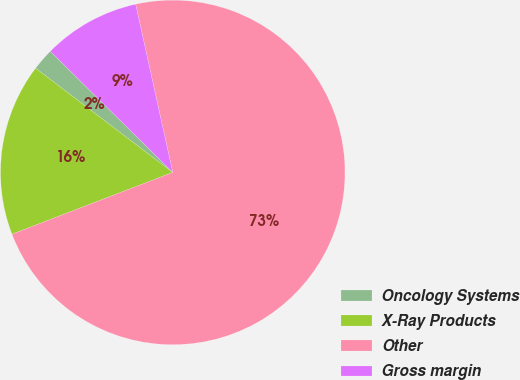<chart> <loc_0><loc_0><loc_500><loc_500><pie_chart><fcel>Oncology Systems<fcel>X-Ray Products<fcel>Other<fcel>Gross margin<nl><fcel>2.07%<fcel>16.18%<fcel>72.61%<fcel>9.13%<nl></chart> 